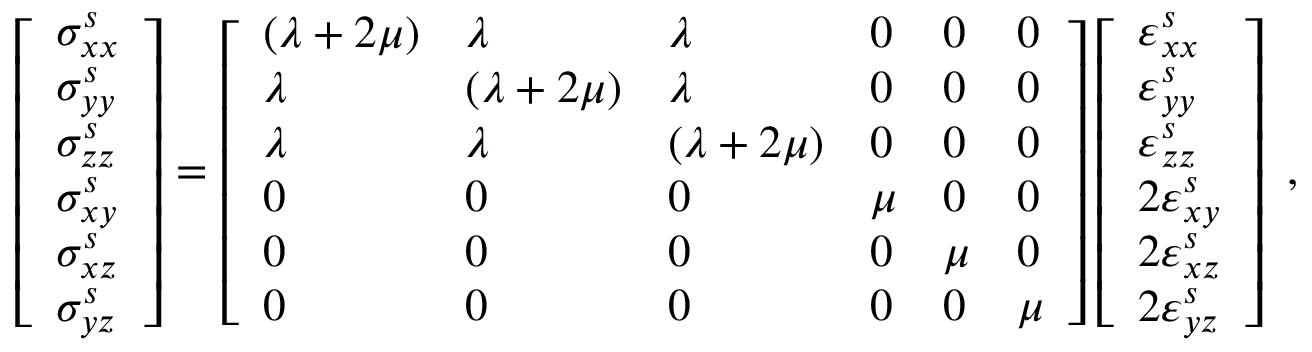<formula> <loc_0><loc_0><loc_500><loc_500>\begin{array} { r } { \left [ \begin{array} { l } { \sigma _ { x x } ^ { s } } \\ { \sigma _ { y y } ^ { s } } \\ { \sigma _ { z z } ^ { s } } \\ { \sigma _ { x y } ^ { s } } \\ { \sigma _ { x z } ^ { s } } \\ { \sigma _ { y z } ^ { s } } \end{array} \right ] = \left [ \begin{array} { l l l l l l } { ( \lambda + 2 \mu ) } & { \lambda } & { \lambda } & { 0 } & { 0 } & { 0 } \\ { \lambda } & { ( \lambda + 2 \mu ) } & { \lambda } & { 0 } & { 0 } & { 0 } \\ { \lambda } & { \lambda } & { ( \lambda + 2 \mu ) } & { 0 } & { 0 } & { 0 } \\ { 0 } & { 0 } & { 0 } & { \mu } & { 0 } & { 0 } \\ { 0 } & { 0 } & { 0 } & { 0 } & { \mu } & { 0 } \\ { 0 } & { 0 } & { 0 } & { 0 } & { 0 } & { \mu } \end{array} \right ] \left [ \begin{array} { l } { \varepsilon _ { x x } ^ { s } } \\ { \varepsilon _ { y y } ^ { s } } \\ { \varepsilon _ { z z } ^ { s } } \\ { 2 \varepsilon _ { x y } ^ { s } } \\ { 2 \varepsilon _ { x z } ^ { s } } \\ { 2 \varepsilon _ { y z } ^ { s } } \end{array} \right ] } \end{array} ,</formula> 